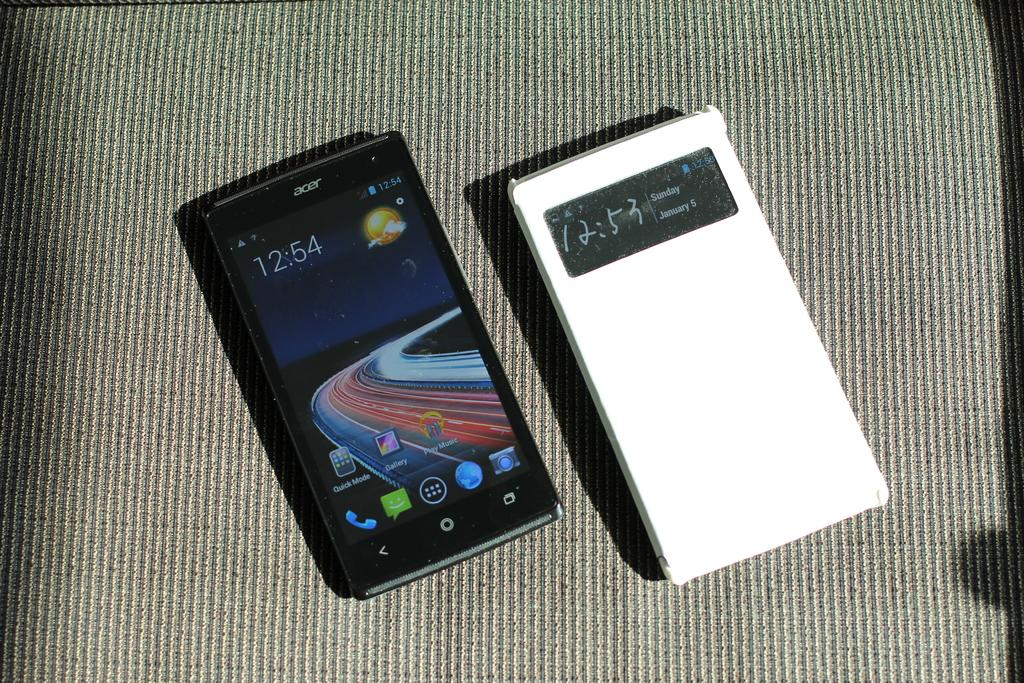<image>
Offer a succinct explanation of the picture presented. The phone on the left hand side shows the time as 12:54. 